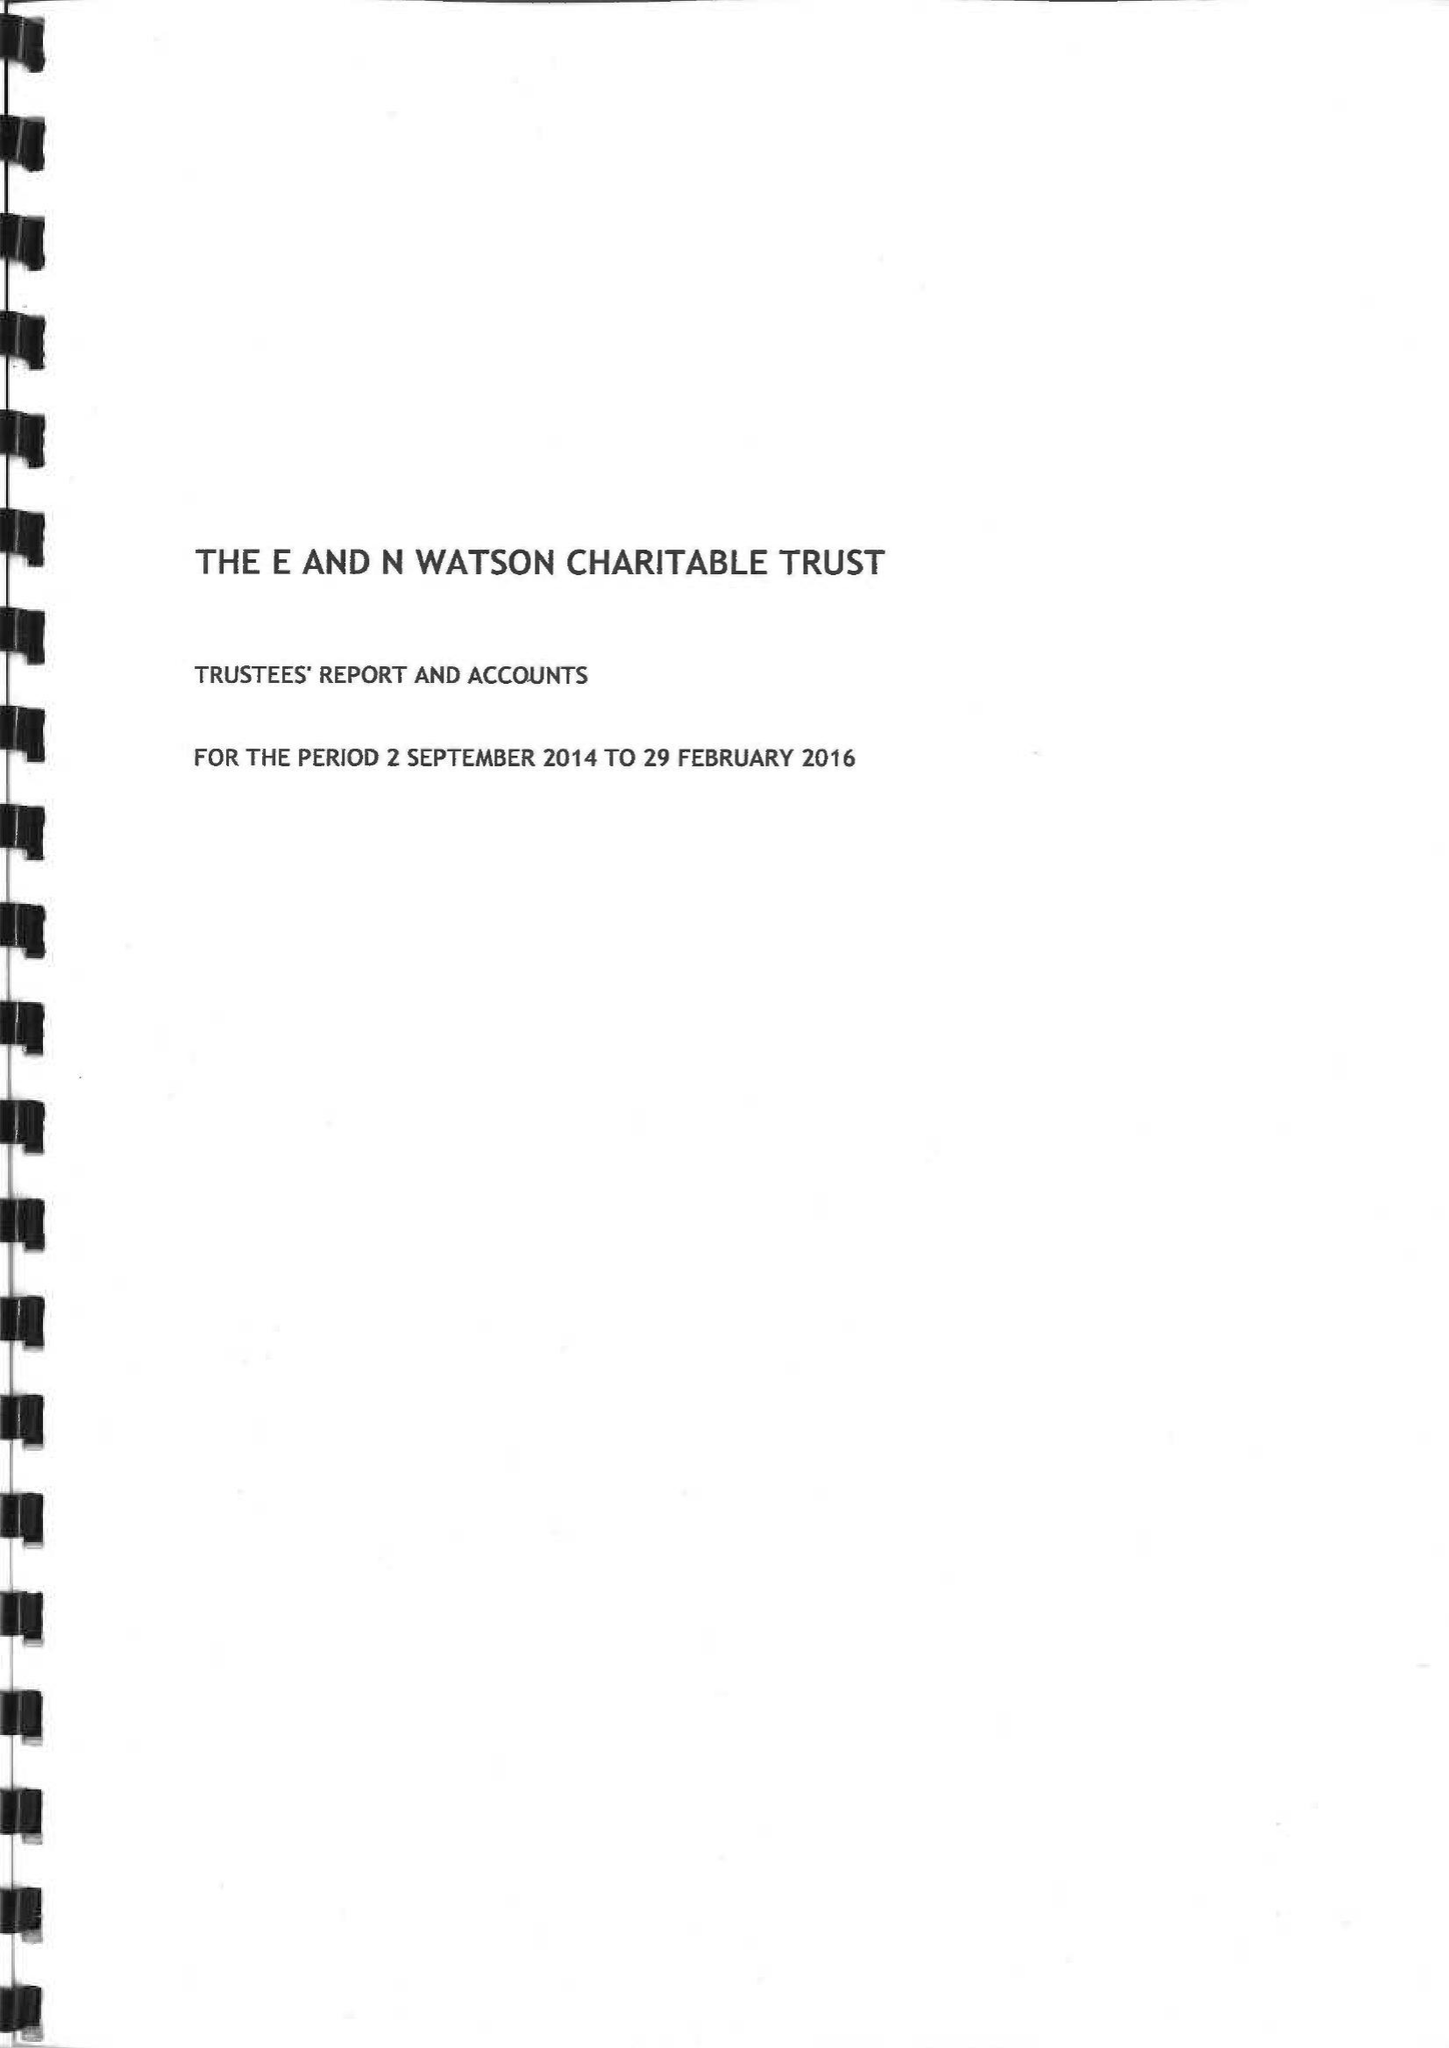What is the value for the charity_name?
Answer the question using a single word or phrase. The E and N Watson Charity 